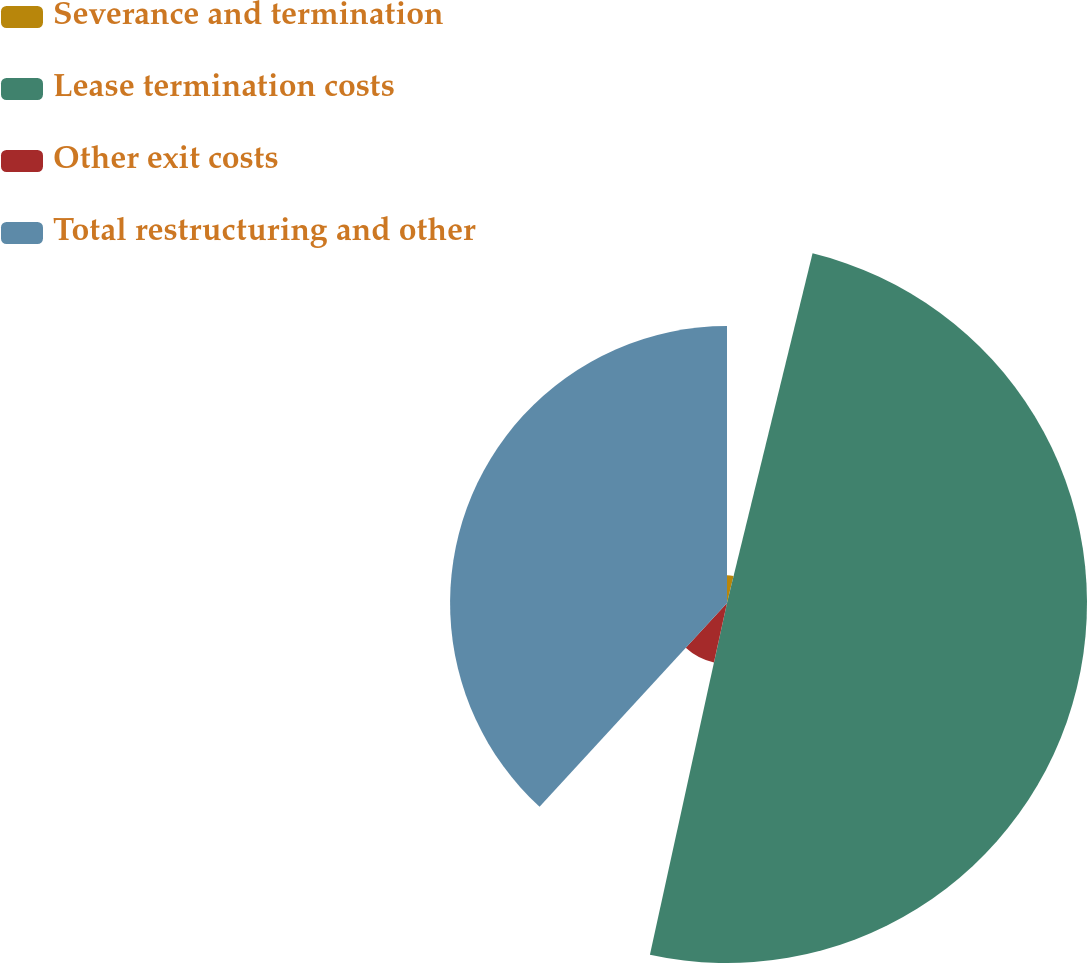Convert chart to OTSL. <chart><loc_0><loc_0><loc_500><loc_500><pie_chart><fcel>Severance and termination<fcel>Lease termination costs<fcel>Other exit costs<fcel>Total restructuring and other<nl><fcel>3.82%<fcel>49.62%<fcel>8.4%<fcel>38.17%<nl></chart> 